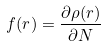<formula> <loc_0><loc_0><loc_500><loc_500>f ( r ) = \frac { \partial \rho ( r ) } { \partial N }</formula> 